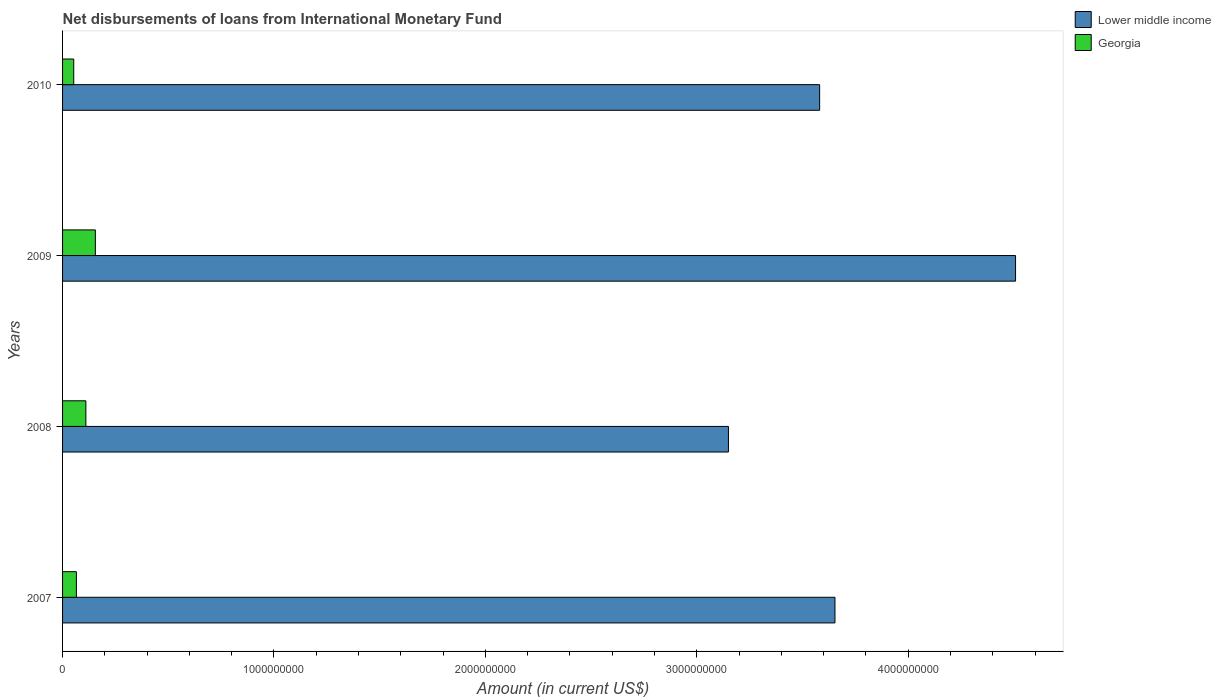Are the number of bars per tick equal to the number of legend labels?
Make the answer very short. Yes. Are the number of bars on each tick of the Y-axis equal?
Your response must be concise. Yes. How many bars are there on the 4th tick from the bottom?
Offer a very short reply. 2. What is the amount of loans disbursed in Lower middle income in 2009?
Ensure brevity in your answer.  4.51e+09. Across all years, what is the maximum amount of loans disbursed in Lower middle income?
Your response must be concise. 4.51e+09. Across all years, what is the minimum amount of loans disbursed in Lower middle income?
Make the answer very short. 3.15e+09. In which year was the amount of loans disbursed in Lower middle income maximum?
Offer a terse response. 2009. What is the total amount of loans disbursed in Lower middle income in the graph?
Offer a terse response. 1.49e+1. What is the difference between the amount of loans disbursed in Lower middle income in 2009 and that in 2010?
Your answer should be very brief. 9.27e+08. What is the difference between the amount of loans disbursed in Lower middle income in 2008 and the amount of loans disbursed in Georgia in 2007?
Provide a succinct answer. 3.08e+09. What is the average amount of loans disbursed in Georgia per year?
Offer a very short reply. 9.59e+07. In the year 2008, what is the difference between the amount of loans disbursed in Georgia and amount of loans disbursed in Lower middle income?
Your answer should be very brief. -3.04e+09. What is the ratio of the amount of loans disbursed in Lower middle income in 2009 to that in 2010?
Make the answer very short. 1.26. Is the amount of loans disbursed in Lower middle income in 2007 less than that in 2010?
Give a very brief answer. No. Is the difference between the amount of loans disbursed in Georgia in 2007 and 2010 greater than the difference between the amount of loans disbursed in Lower middle income in 2007 and 2010?
Ensure brevity in your answer.  No. What is the difference between the highest and the second highest amount of loans disbursed in Georgia?
Offer a very short reply. 4.49e+07. What is the difference between the highest and the lowest amount of loans disbursed in Lower middle income?
Your response must be concise. 1.36e+09. In how many years, is the amount of loans disbursed in Lower middle income greater than the average amount of loans disbursed in Lower middle income taken over all years?
Your response must be concise. 1. What does the 2nd bar from the top in 2008 represents?
Offer a very short reply. Lower middle income. What does the 1st bar from the bottom in 2007 represents?
Your answer should be very brief. Lower middle income. Are all the bars in the graph horizontal?
Your response must be concise. Yes. Does the graph contain grids?
Your answer should be very brief. No. How many legend labels are there?
Give a very brief answer. 2. How are the legend labels stacked?
Offer a very short reply. Vertical. What is the title of the graph?
Offer a terse response. Net disbursements of loans from International Monetary Fund. What is the label or title of the Y-axis?
Keep it short and to the point. Years. What is the Amount (in current US$) of Lower middle income in 2007?
Your answer should be compact. 3.65e+09. What is the Amount (in current US$) of Georgia in 2007?
Your answer should be very brief. 6.54e+07. What is the Amount (in current US$) in Lower middle income in 2008?
Your response must be concise. 3.15e+09. What is the Amount (in current US$) in Georgia in 2008?
Make the answer very short. 1.10e+08. What is the Amount (in current US$) of Lower middle income in 2009?
Make the answer very short. 4.51e+09. What is the Amount (in current US$) in Georgia in 2009?
Offer a very short reply. 1.55e+08. What is the Amount (in current US$) of Lower middle income in 2010?
Offer a very short reply. 3.58e+09. What is the Amount (in current US$) in Georgia in 2010?
Give a very brief answer. 5.29e+07. Across all years, what is the maximum Amount (in current US$) of Lower middle income?
Provide a short and direct response. 4.51e+09. Across all years, what is the maximum Amount (in current US$) in Georgia?
Your answer should be very brief. 1.55e+08. Across all years, what is the minimum Amount (in current US$) in Lower middle income?
Provide a short and direct response. 3.15e+09. Across all years, what is the minimum Amount (in current US$) in Georgia?
Ensure brevity in your answer.  5.29e+07. What is the total Amount (in current US$) in Lower middle income in the graph?
Your response must be concise. 1.49e+1. What is the total Amount (in current US$) of Georgia in the graph?
Give a very brief answer. 3.84e+08. What is the difference between the Amount (in current US$) in Lower middle income in 2007 and that in 2008?
Offer a very short reply. 5.04e+08. What is the difference between the Amount (in current US$) in Georgia in 2007 and that in 2008?
Offer a terse response. -4.48e+07. What is the difference between the Amount (in current US$) in Lower middle income in 2007 and that in 2009?
Your answer should be very brief. -8.54e+08. What is the difference between the Amount (in current US$) in Georgia in 2007 and that in 2009?
Provide a short and direct response. -8.98e+07. What is the difference between the Amount (in current US$) in Lower middle income in 2007 and that in 2010?
Your response must be concise. 7.25e+07. What is the difference between the Amount (in current US$) in Georgia in 2007 and that in 2010?
Your answer should be compact. 1.25e+07. What is the difference between the Amount (in current US$) in Lower middle income in 2008 and that in 2009?
Make the answer very short. -1.36e+09. What is the difference between the Amount (in current US$) in Georgia in 2008 and that in 2009?
Ensure brevity in your answer.  -4.49e+07. What is the difference between the Amount (in current US$) of Lower middle income in 2008 and that in 2010?
Your response must be concise. -4.31e+08. What is the difference between the Amount (in current US$) in Georgia in 2008 and that in 2010?
Your answer should be very brief. 5.73e+07. What is the difference between the Amount (in current US$) in Lower middle income in 2009 and that in 2010?
Provide a succinct answer. 9.27e+08. What is the difference between the Amount (in current US$) of Georgia in 2009 and that in 2010?
Your answer should be very brief. 1.02e+08. What is the difference between the Amount (in current US$) of Lower middle income in 2007 and the Amount (in current US$) of Georgia in 2008?
Your answer should be very brief. 3.54e+09. What is the difference between the Amount (in current US$) of Lower middle income in 2007 and the Amount (in current US$) of Georgia in 2009?
Your answer should be compact. 3.50e+09. What is the difference between the Amount (in current US$) in Lower middle income in 2007 and the Amount (in current US$) in Georgia in 2010?
Ensure brevity in your answer.  3.60e+09. What is the difference between the Amount (in current US$) of Lower middle income in 2008 and the Amount (in current US$) of Georgia in 2009?
Offer a very short reply. 2.99e+09. What is the difference between the Amount (in current US$) of Lower middle income in 2008 and the Amount (in current US$) of Georgia in 2010?
Your answer should be very brief. 3.10e+09. What is the difference between the Amount (in current US$) in Lower middle income in 2009 and the Amount (in current US$) in Georgia in 2010?
Provide a succinct answer. 4.46e+09. What is the average Amount (in current US$) of Lower middle income per year?
Provide a succinct answer. 3.72e+09. What is the average Amount (in current US$) in Georgia per year?
Your answer should be compact. 9.59e+07. In the year 2007, what is the difference between the Amount (in current US$) of Lower middle income and Amount (in current US$) of Georgia?
Provide a succinct answer. 3.59e+09. In the year 2008, what is the difference between the Amount (in current US$) of Lower middle income and Amount (in current US$) of Georgia?
Your answer should be very brief. 3.04e+09. In the year 2009, what is the difference between the Amount (in current US$) of Lower middle income and Amount (in current US$) of Georgia?
Offer a very short reply. 4.35e+09. In the year 2010, what is the difference between the Amount (in current US$) in Lower middle income and Amount (in current US$) in Georgia?
Provide a short and direct response. 3.53e+09. What is the ratio of the Amount (in current US$) of Lower middle income in 2007 to that in 2008?
Make the answer very short. 1.16. What is the ratio of the Amount (in current US$) in Georgia in 2007 to that in 2008?
Keep it short and to the point. 0.59. What is the ratio of the Amount (in current US$) of Lower middle income in 2007 to that in 2009?
Offer a very short reply. 0.81. What is the ratio of the Amount (in current US$) in Georgia in 2007 to that in 2009?
Offer a terse response. 0.42. What is the ratio of the Amount (in current US$) in Lower middle income in 2007 to that in 2010?
Your answer should be very brief. 1.02. What is the ratio of the Amount (in current US$) of Georgia in 2007 to that in 2010?
Ensure brevity in your answer.  1.24. What is the ratio of the Amount (in current US$) of Lower middle income in 2008 to that in 2009?
Make the answer very short. 0.7. What is the ratio of the Amount (in current US$) in Georgia in 2008 to that in 2009?
Ensure brevity in your answer.  0.71. What is the ratio of the Amount (in current US$) in Lower middle income in 2008 to that in 2010?
Offer a terse response. 0.88. What is the ratio of the Amount (in current US$) in Georgia in 2008 to that in 2010?
Your answer should be very brief. 2.08. What is the ratio of the Amount (in current US$) in Lower middle income in 2009 to that in 2010?
Provide a short and direct response. 1.26. What is the ratio of the Amount (in current US$) of Georgia in 2009 to that in 2010?
Give a very brief answer. 2.93. What is the difference between the highest and the second highest Amount (in current US$) in Lower middle income?
Your answer should be very brief. 8.54e+08. What is the difference between the highest and the second highest Amount (in current US$) in Georgia?
Keep it short and to the point. 4.49e+07. What is the difference between the highest and the lowest Amount (in current US$) in Lower middle income?
Keep it short and to the point. 1.36e+09. What is the difference between the highest and the lowest Amount (in current US$) of Georgia?
Offer a terse response. 1.02e+08. 